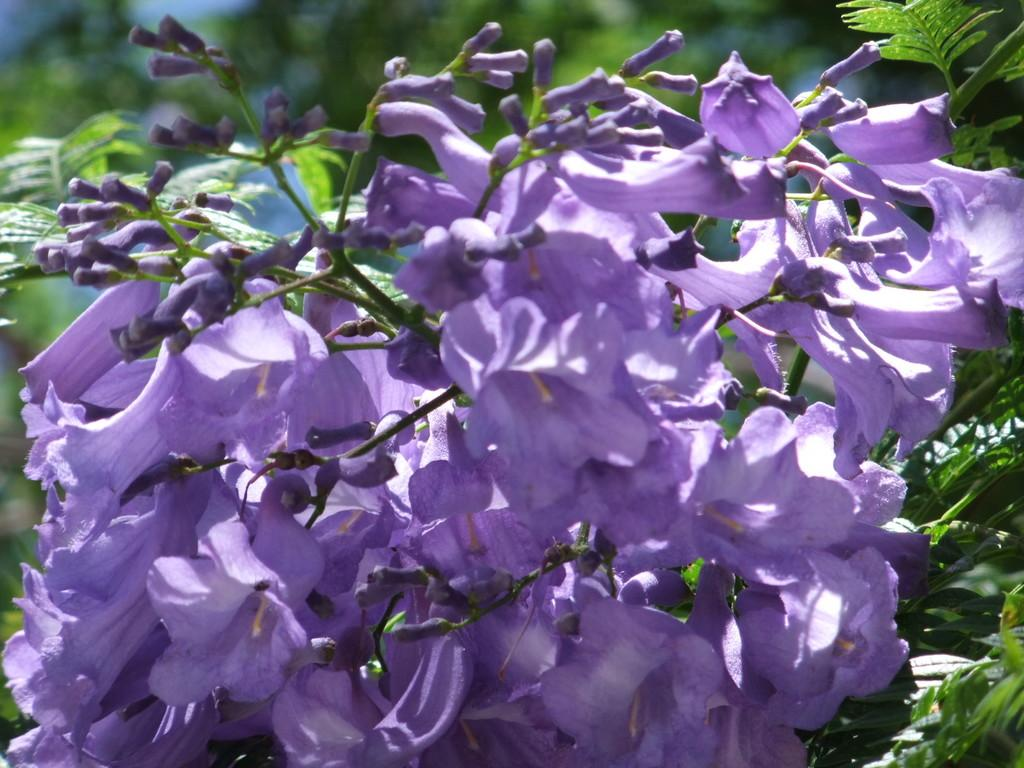What type of plants can be seen in the image? There are plants with flowers in the image. Can you describe the background of the image? The background of the image is blurred. Where is the scarecrow located in the image? There is no scarecrow present in the image. What type of test can be seen being conducted in the image? There is no test being conducted in the image; it features plants with flowers and a blurred background. 